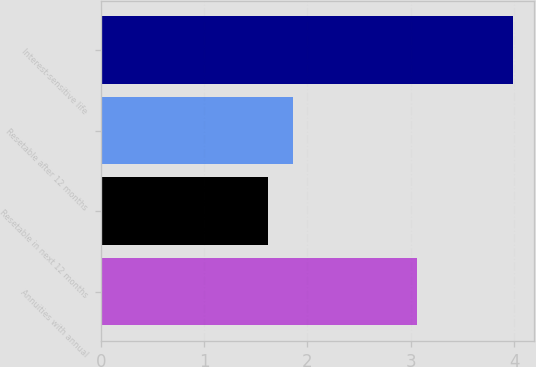Convert chart. <chart><loc_0><loc_0><loc_500><loc_500><bar_chart><fcel>Annuities with annual<fcel>Resetable in next 12 months<fcel>Resetable after 12 months<fcel>Interest-sensitive life<nl><fcel>3.06<fcel>1.62<fcel>1.86<fcel>3.99<nl></chart> 